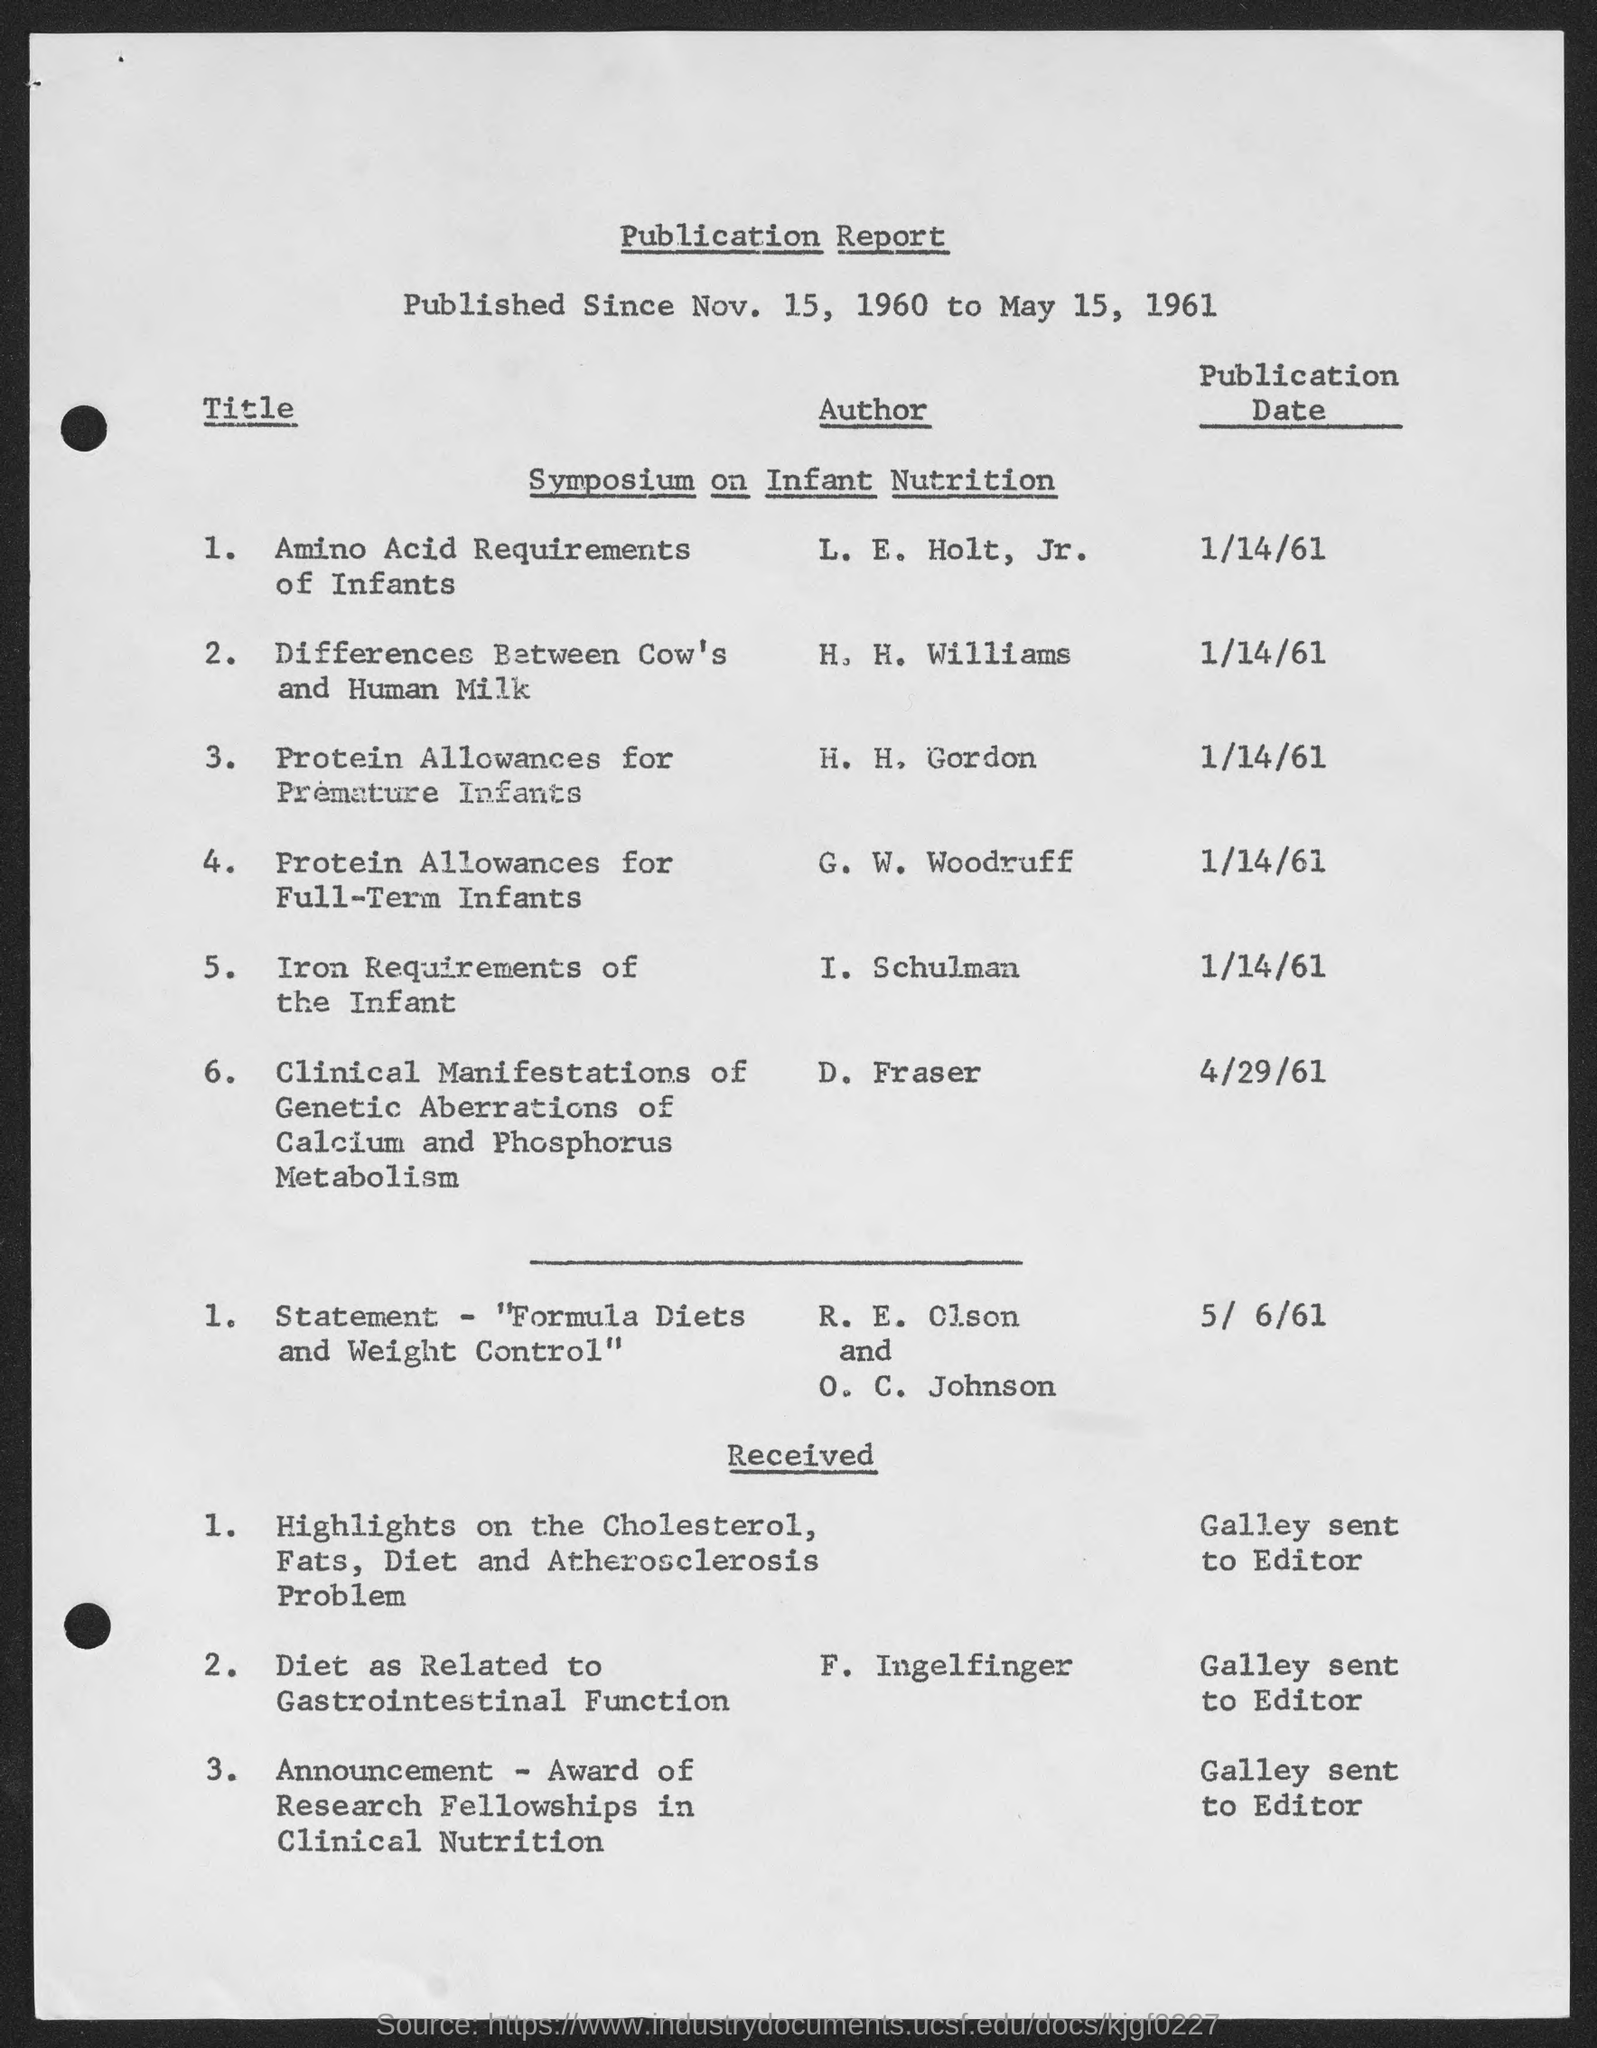Indicate a few pertinent items in this graphic. The publication date of "Amino acid requirements of infants" is January 14th, 1961. The publication date of "Differences between cow's and human milk" is January 14, 1961. The report in question is known as the 'publication report.' The publication date of "Protein Allowances for Full-term Infants" was January 14, 1961. The publication date of 'Clinical Manifestations of Genetic Aberrations of Calcium and Phosphorus Metabolism' is April 29, 1961. 